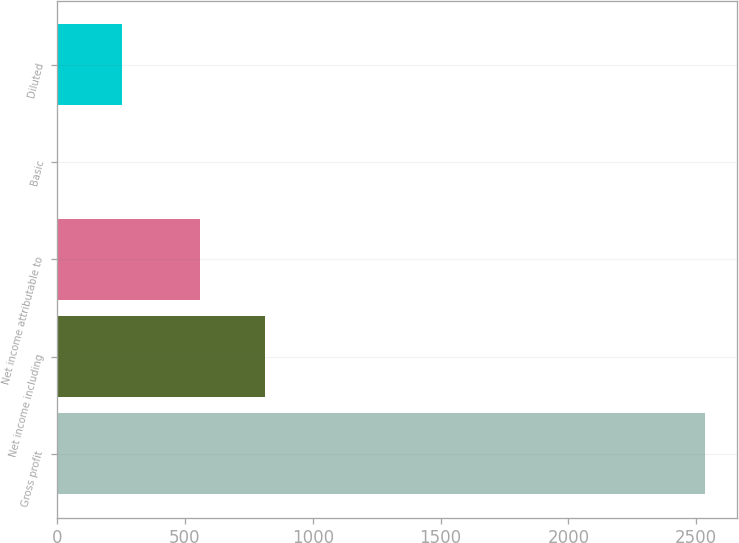Convert chart to OTSL. <chart><loc_0><loc_0><loc_500><loc_500><bar_chart><fcel>Gross profit<fcel>Net income including<fcel>Net income attributable to<fcel>Basic<fcel>Diluted<nl><fcel>2534<fcel>814.34<fcel>561<fcel>0.6<fcel>253.94<nl></chart> 